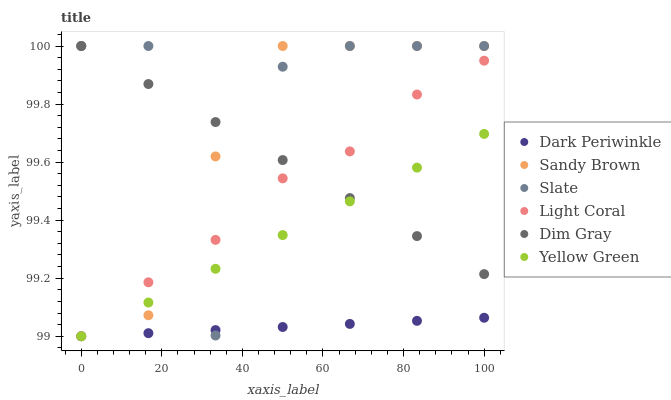Does Dark Periwinkle have the minimum area under the curve?
Answer yes or no. Yes. Does Slate have the maximum area under the curve?
Answer yes or no. Yes. Does Yellow Green have the minimum area under the curve?
Answer yes or no. No. Does Yellow Green have the maximum area under the curve?
Answer yes or no. No. Is Dark Periwinkle the smoothest?
Answer yes or no. Yes. Is Slate the roughest?
Answer yes or no. Yes. Is Yellow Green the smoothest?
Answer yes or no. No. Is Yellow Green the roughest?
Answer yes or no. No. Does Yellow Green have the lowest value?
Answer yes or no. Yes. Does Slate have the lowest value?
Answer yes or no. No. Does Sandy Brown have the highest value?
Answer yes or no. Yes. Does Yellow Green have the highest value?
Answer yes or no. No. Is Dark Periwinkle less than Dim Gray?
Answer yes or no. Yes. Is Dim Gray greater than Dark Periwinkle?
Answer yes or no. Yes. Does Dim Gray intersect Yellow Green?
Answer yes or no. Yes. Is Dim Gray less than Yellow Green?
Answer yes or no. No. Is Dim Gray greater than Yellow Green?
Answer yes or no. No. Does Dark Periwinkle intersect Dim Gray?
Answer yes or no. No. 